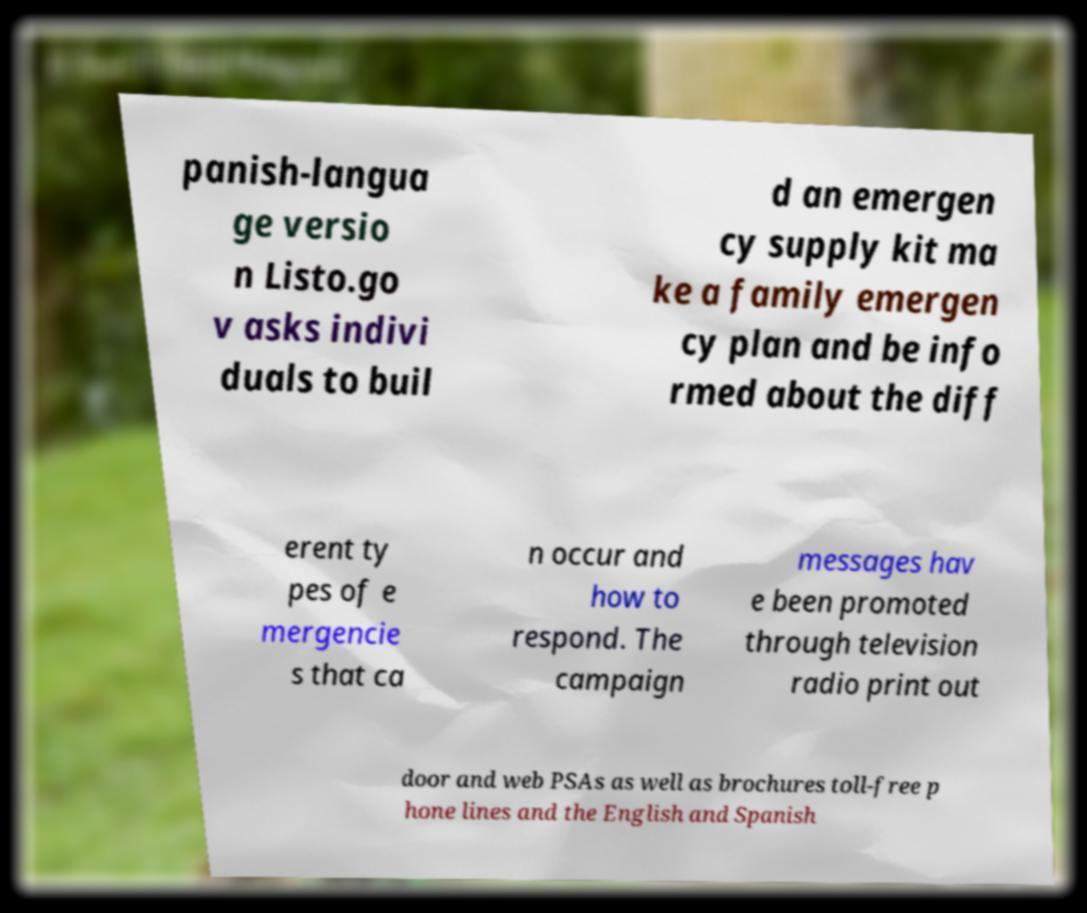I need the written content from this picture converted into text. Can you do that? panish-langua ge versio n Listo.go v asks indivi duals to buil d an emergen cy supply kit ma ke a family emergen cy plan and be info rmed about the diff erent ty pes of e mergencie s that ca n occur and how to respond. The campaign messages hav e been promoted through television radio print out door and web PSAs as well as brochures toll-free p hone lines and the English and Spanish 